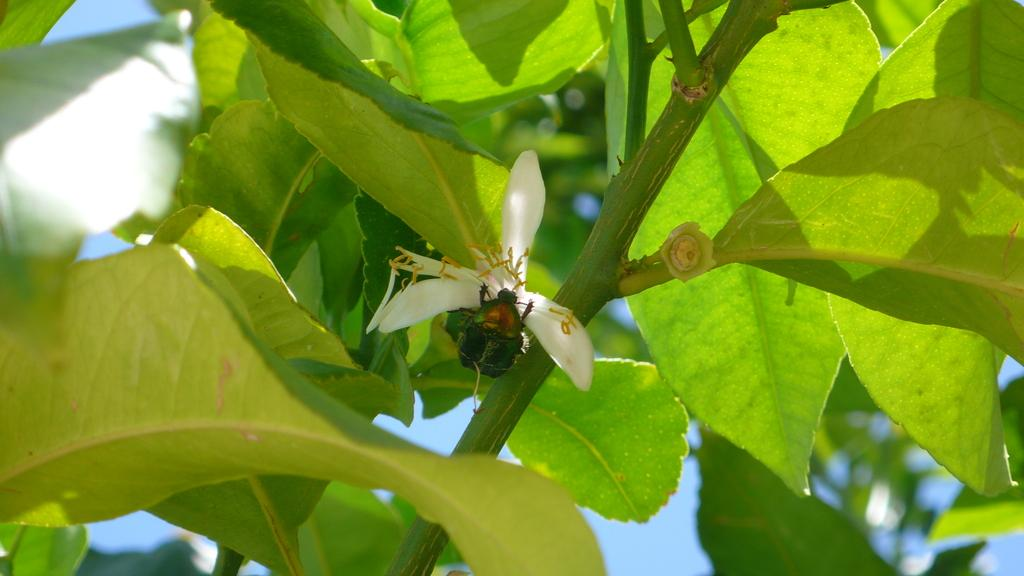What is present on the tree branch in the image? There is a flower and an insect on the tree branch in the image. What color is the sky in the background of the image? The sky is blue in the background of the image. What type of development can be seen in the image? There is no development or construction project present in the image; it features a tree branch with a flower and insect. What type of skirt is the owl wearing in the image? There is no owl present in the image, and therefore no skirt or clothing can be observed. 